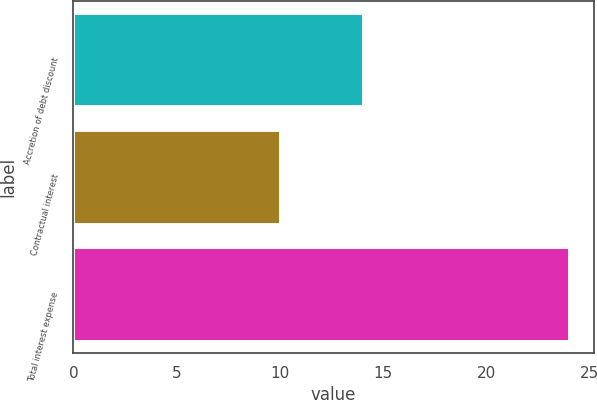Convert chart. <chart><loc_0><loc_0><loc_500><loc_500><bar_chart><fcel>Accretion of debt discount<fcel>Contractual interest<fcel>Total interest expense<nl><fcel>14<fcel>10<fcel>24<nl></chart> 